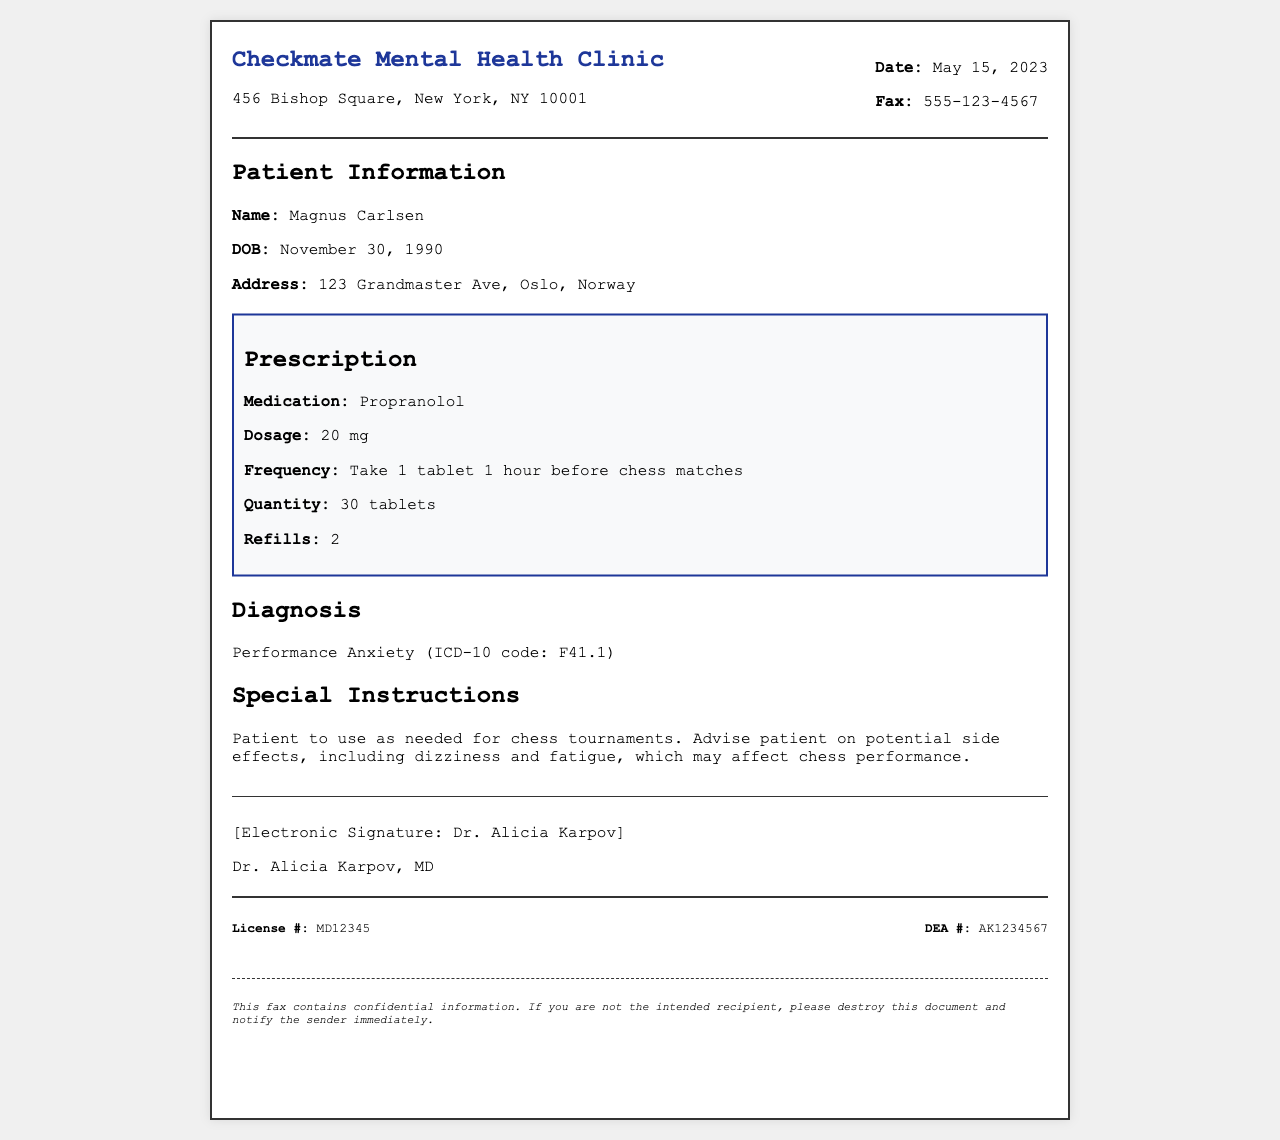What is the name of the clinic? The name of the clinic can be found in the header of the document.
Answer: Checkmate Mental Health Clinic What is the medication prescribed? The prescribed medication is listed under the prescription section.
Answer: Propranolol Who is the patient? The patient's name is mentioned in the patient information section.
Answer: Magnus Carlsen What is the diagnosis according to the document? The diagnosis is specified in the diagnosis section with an ICD-10 code.
Answer: Performance Anxiety (ICD-10 code: F41.1) What is the dosage for the prescribed medication? The dosage is indicated in the prescription section of the document.
Answer: 20 mg How many tablets are included in the prescription? The quantity of tablets prescribed is provided in the prescription section.
Answer: 30 tablets What is the fax number for the clinic? The fax number is listed in the header of the document.
Answer: 555-123-4567 What special instructions are provided for the patient? Special instructions are detailed at the end of the document.
Answer: Patient to use as needed for chess tournaments What is Dr. Alicia Karpov's license number? The license number is included in the footer of the document.
Answer: MD12345 